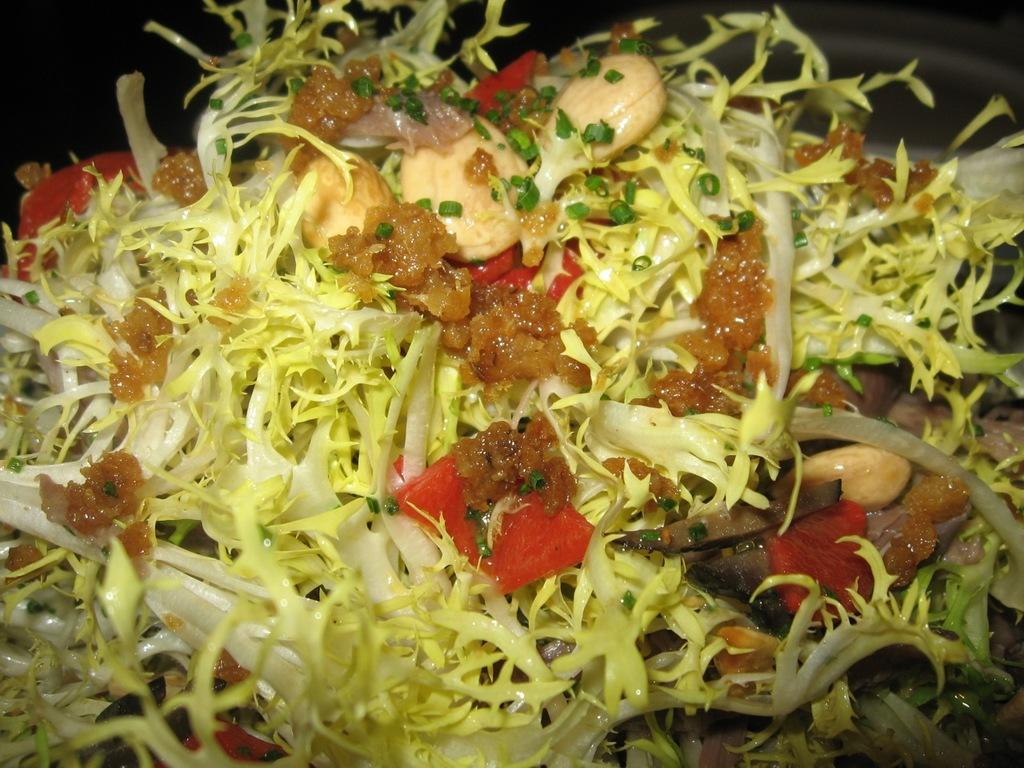What type of food item can be seen in the image? There is a cooked food item in the image. What type of insurance policy is mentioned in the image? There is no mention of an insurance policy in the image; it only features a cooked food item. Is there a tent visible in the image? No, there is no tent present in the image. 